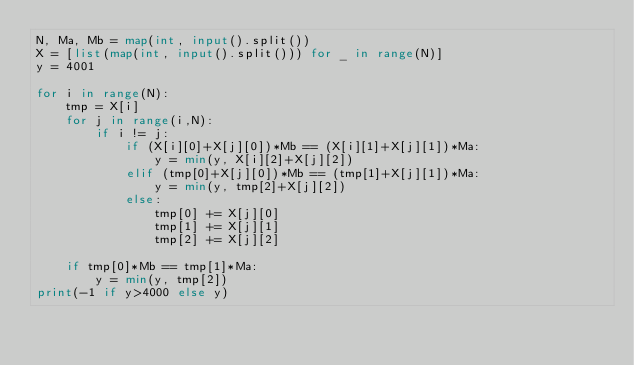Convert code to text. <code><loc_0><loc_0><loc_500><loc_500><_Python_>N, Ma, Mb = map(int, input().split())
X = [list(map(int, input().split())) for _ in range(N)]
y = 4001

for i in range(N):
    tmp = X[i]
    for j in range(i,N):
        if i != j:
            if (X[i][0]+X[j][0])*Mb == (X[i][1]+X[j][1])*Ma:
                y = min(y, X[i][2]+X[j][2])
            elif (tmp[0]+X[j][0])*Mb == (tmp[1]+X[j][1])*Ma:
                y = min(y, tmp[2]+X[j][2])
            else:
                tmp[0] += X[j][0]
                tmp[1] += X[j][1]
                tmp[2] += X[j][2]
                
    if tmp[0]*Mb == tmp[1]*Ma:
        y = min(y, tmp[2])
print(-1 if y>4000 else y)</code> 